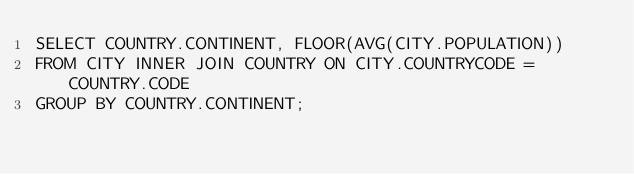<code> <loc_0><loc_0><loc_500><loc_500><_SQL_>SELECT COUNTRY.CONTINENT, FLOOR(AVG(CITY.POPULATION)) 
FROM CITY INNER JOIN COUNTRY ON CITY.COUNTRYCODE = COUNTRY.CODE
GROUP BY COUNTRY.CONTINENT;
</code> 